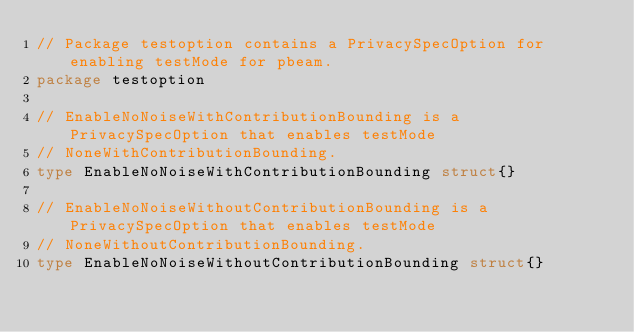<code> <loc_0><loc_0><loc_500><loc_500><_Go_>// Package testoption contains a PrivacySpecOption for enabling testMode for pbeam.
package testoption

// EnableNoNoiseWithContributionBounding is a PrivacySpecOption that enables testMode
// NoneWithContributionBounding.
type EnableNoNoiseWithContributionBounding struct{}

// EnableNoNoiseWithoutContributionBounding is a PrivacySpecOption that enables testMode
// NoneWithoutContributionBounding.
type EnableNoNoiseWithoutContributionBounding struct{}
</code> 